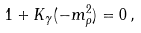<formula> <loc_0><loc_0><loc_500><loc_500>1 + K _ { \gamma } ( - m _ { \rho } ^ { 2 } ) = 0 \, ,</formula> 